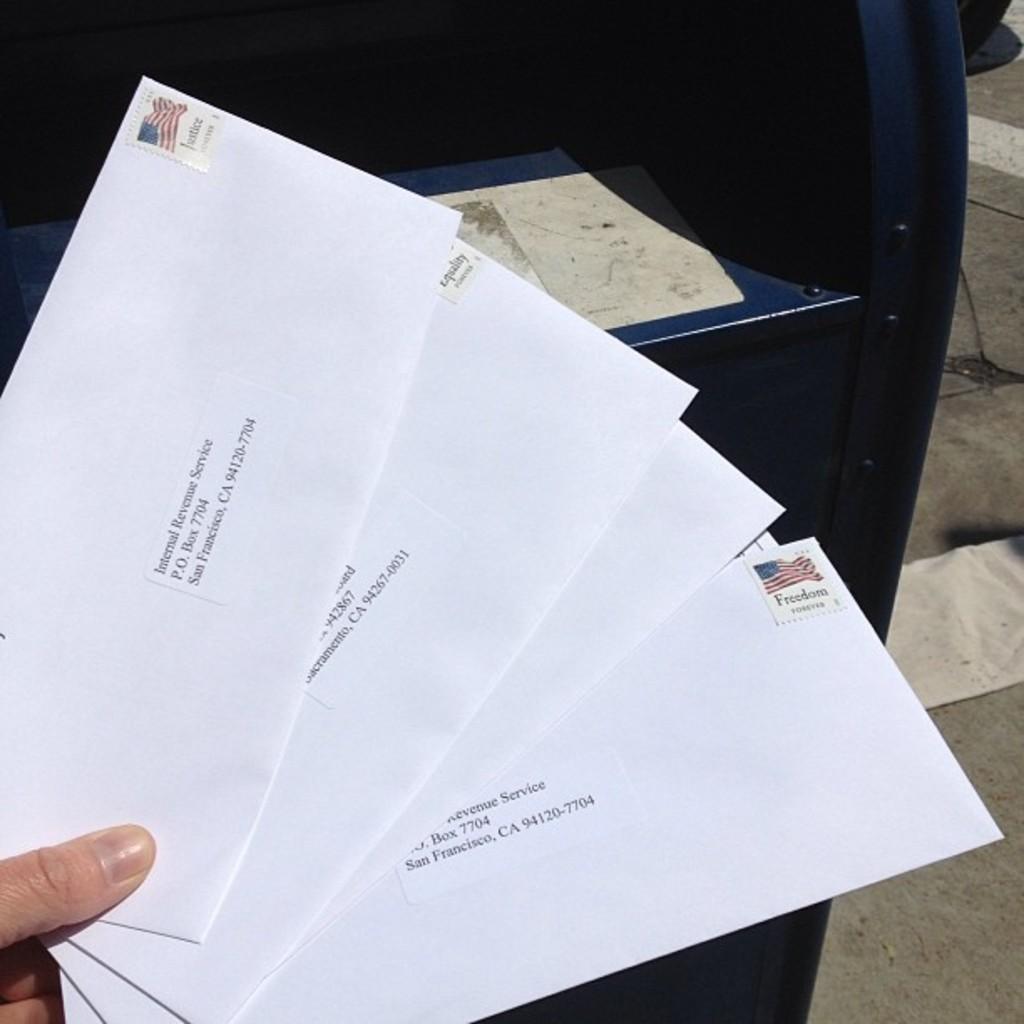What is the po box of the letter on top?
Provide a short and direct response. 7704. Who is the top letter to?
Keep it short and to the point. Internal revenue service. 